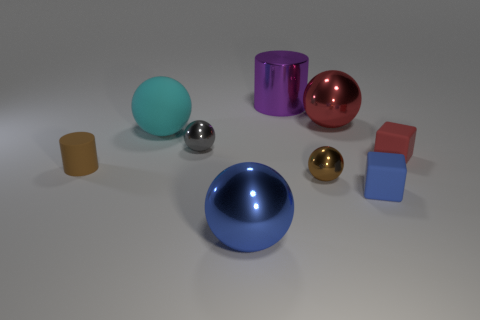There is a large shiny sphere that is in front of the red shiny sphere; does it have the same color as the big metallic cylinder?
Provide a succinct answer. No. How many other objects are there of the same size as the red cube?
Provide a short and direct response. 4. Is the large blue sphere made of the same material as the big red sphere?
Ensure brevity in your answer.  Yes. There is a small cube in front of the small brown object that is to the left of the cyan ball; what is its color?
Make the answer very short. Blue. The other thing that is the same shape as the tiny red rubber object is what size?
Provide a short and direct response. Small. Does the tiny rubber cylinder have the same color as the big cylinder?
Ensure brevity in your answer.  No. There is a small ball that is left of the cylinder that is behind the red cube; what number of matte objects are to the left of it?
Offer a very short reply. 2. Are there more small cylinders than red metal blocks?
Make the answer very short. Yes. What number of red objects are there?
Keep it short and to the point. 2. There is a tiny metal thing right of the small ball to the left of the cylinder behind the red matte block; what is its shape?
Offer a very short reply. Sphere. 